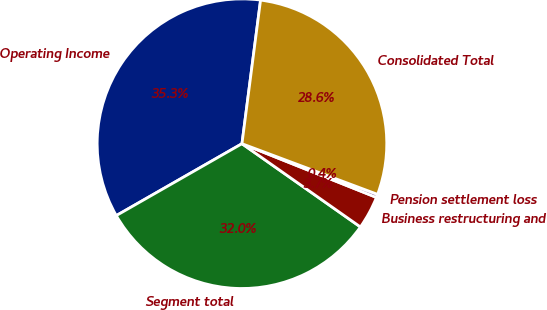Convert chart to OTSL. <chart><loc_0><loc_0><loc_500><loc_500><pie_chart><fcel>Operating Income<fcel>Segment total<fcel>Business restructuring and<fcel>Pension settlement loss<fcel>Consolidated Total<nl><fcel>35.32%<fcel>31.98%<fcel>3.7%<fcel>0.36%<fcel>28.64%<nl></chart> 